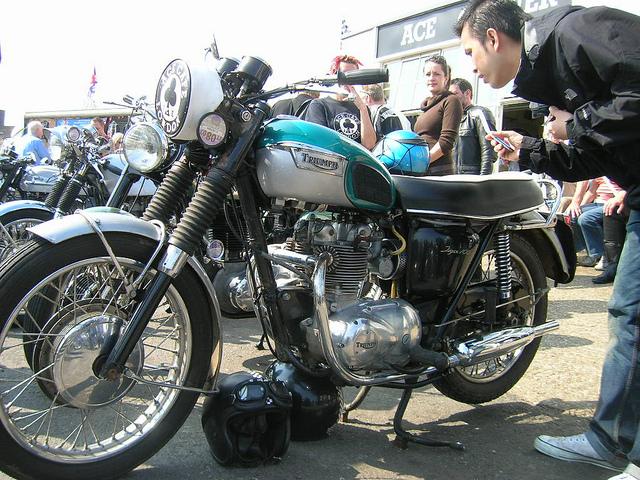Do you think this bike is new?
Keep it brief. Yes. Does this motorcycle run?
Quick response, please. Yes. What is the number displayed in the motorcycle?
Write a very short answer. 80. Is he taking a picture?
Short answer required. Yes. What brand of motorcycle is this?
Short answer required. Triumph. How many different shades of blue are on the motorcycle?
Short answer required. 1. What color is the bike?
Short answer required. Blue. Is he wearing dress shoes?
Quick response, please. No. 